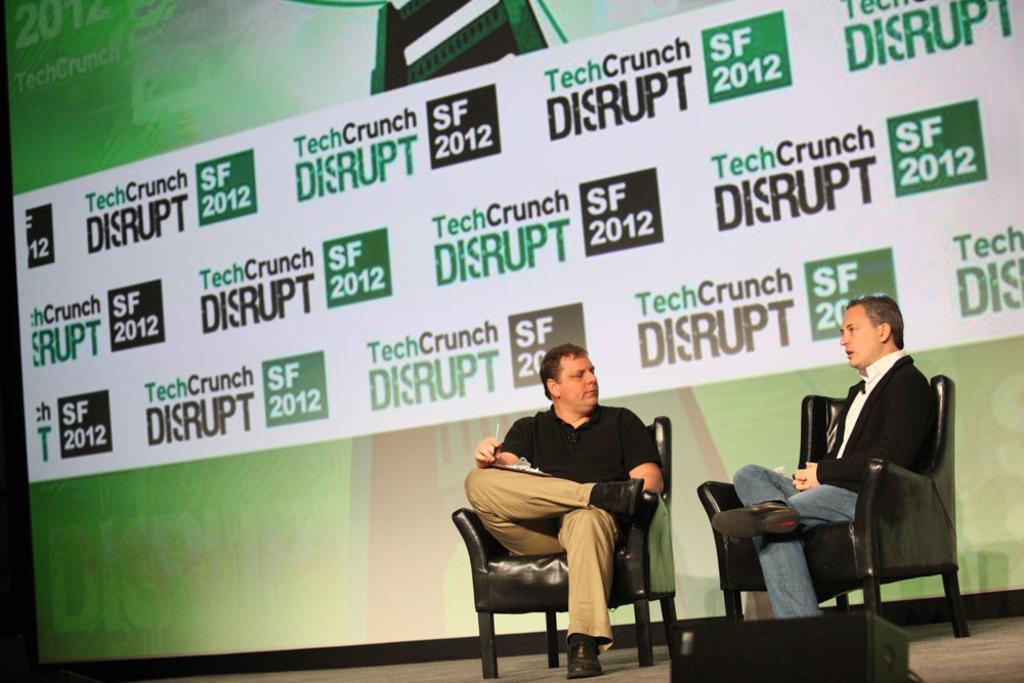Could you give a brief overview of what you see in this image? There are two persons sitting on chairs. A person wearing a black and brown dress is holding a writing pad. In the background there is a banner. In the front there is a speaker. 